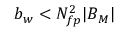Convert formula to latex. <formula><loc_0><loc_0><loc_500><loc_500>b _ { w } < N _ { f p } ^ { 2 } | B _ { M } |</formula> 